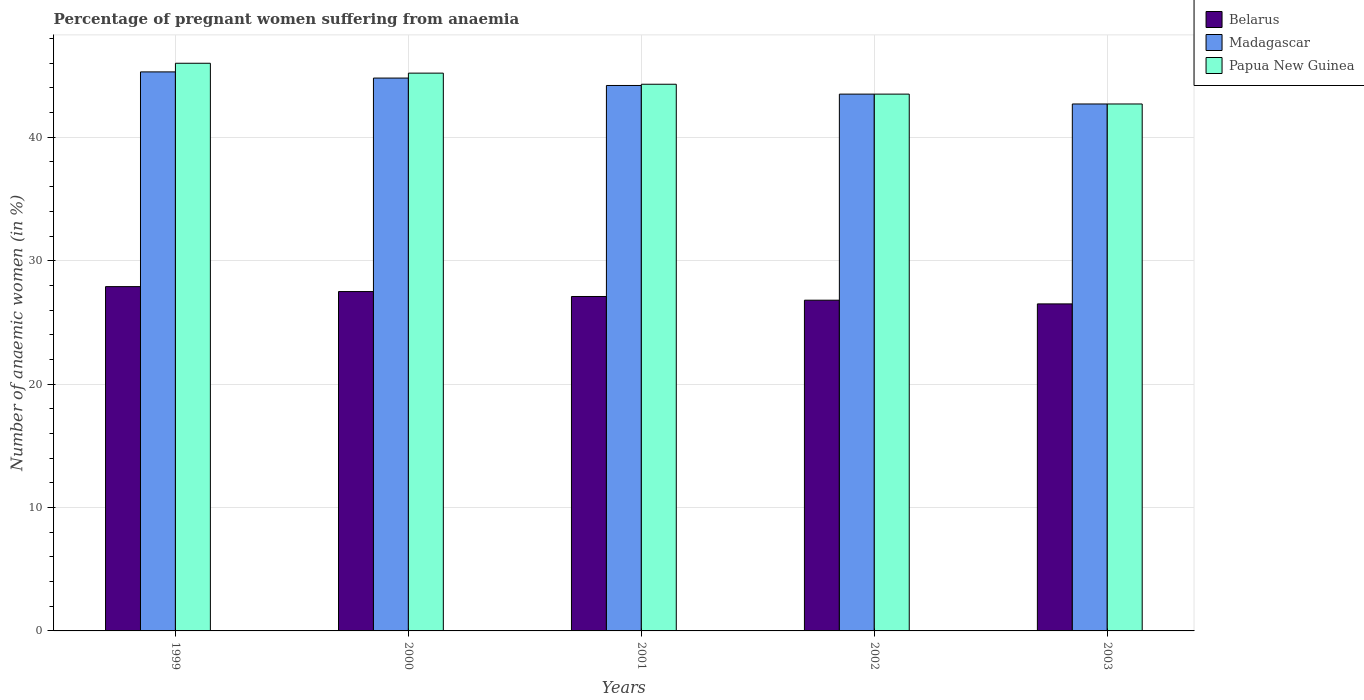Are the number of bars per tick equal to the number of legend labels?
Your answer should be very brief. Yes. Are the number of bars on each tick of the X-axis equal?
Your response must be concise. Yes. How many bars are there on the 4th tick from the left?
Ensure brevity in your answer.  3. What is the label of the 2nd group of bars from the left?
Offer a very short reply. 2000. What is the number of anaemic women in Madagascar in 1999?
Make the answer very short. 45.3. Across all years, what is the maximum number of anaemic women in Belarus?
Provide a succinct answer. 27.9. Across all years, what is the minimum number of anaemic women in Papua New Guinea?
Ensure brevity in your answer.  42.7. What is the total number of anaemic women in Papua New Guinea in the graph?
Your answer should be compact. 221.7. What is the difference between the number of anaemic women in Papua New Guinea in 2000 and that in 2002?
Your response must be concise. 1.7. What is the difference between the number of anaemic women in Papua New Guinea in 2000 and the number of anaemic women in Belarus in 2001?
Your response must be concise. 18.1. What is the average number of anaemic women in Madagascar per year?
Your answer should be very brief. 44.1. In the year 2003, what is the difference between the number of anaemic women in Belarus and number of anaemic women in Madagascar?
Give a very brief answer. -16.2. In how many years, is the number of anaemic women in Madagascar greater than 22 %?
Ensure brevity in your answer.  5. What is the ratio of the number of anaemic women in Madagascar in 2000 to that in 2003?
Your response must be concise. 1.05. Is the number of anaemic women in Madagascar in 2001 less than that in 2003?
Provide a succinct answer. No. Is the difference between the number of anaemic women in Belarus in 2000 and 2001 greater than the difference between the number of anaemic women in Madagascar in 2000 and 2001?
Provide a succinct answer. No. What is the difference between the highest and the second highest number of anaemic women in Madagascar?
Offer a very short reply. 0.5. What is the difference between the highest and the lowest number of anaemic women in Belarus?
Keep it short and to the point. 1.4. In how many years, is the number of anaemic women in Papua New Guinea greater than the average number of anaemic women in Papua New Guinea taken over all years?
Your answer should be compact. 2. What does the 1st bar from the left in 2003 represents?
Give a very brief answer. Belarus. What does the 3rd bar from the right in 2001 represents?
Offer a very short reply. Belarus. How many bars are there?
Give a very brief answer. 15. Are all the bars in the graph horizontal?
Provide a succinct answer. No. What is the difference between two consecutive major ticks on the Y-axis?
Your answer should be compact. 10. Are the values on the major ticks of Y-axis written in scientific E-notation?
Keep it short and to the point. No. How are the legend labels stacked?
Your answer should be very brief. Vertical. What is the title of the graph?
Provide a short and direct response. Percentage of pregnant women suffering from anaemia. What is the label or title of the Y-axis?
Provide a short and direct response. Number of anaemic women (in %). What is the Number of anaemic women (in %) in Belarus in 1999?
Your response must be concise. 27.9. What is the Number of anaemic women (in %) of Madagascar in 1999?
Give a very brief answer. 45.3. What is the Number of anaemic women (in %) in Papua New Guinea in 1999?
Give a very brief answer. 46. What is the Number of anaemic women (in %) of Belarus in 2000?
Provide a succinct answer. 27.5. What is the Number of anaemic women (in %) in Madagascar in 2000?
Your response must be concise. 44.8. What is the Number of anaemic women (in %) of Papua New Guinea in 2000?
Your answer should be compact. 45.2. What is the Number of anaemic women (in %) of Belarus in 2001?
Provide a succinct answer. 27.1. What is the Number of anaemic women (in %) in Madagascar in 2001?
Offer a very short reply. 44.2. What is the Number of anaemic women (in %) of Papua New Guinea in 2001?
Your response must be concise. 44.3. What is the Number of anaemic women (in %) in Belarus in 2002?
Offer a terse response. 26.8. What is the Number of anaemic women (in %) of Madagascar in 2002?
Keep it short and to the point. 43.5. What is the Number of anaemic women (in %) of Papua New Guinea in 2002?
Offer a terse response. 43.5. What is the Number of anaemic women (in %) in Belarus in 2003?
Give a very brief answer. 26.5. What is the Number of anaemic women (in %) in Madagascar in 2003?
Your response must be concise. 42.7. What is the Number of anaemic women (in %) in Papua New Guinea in 2003?
Your response must be concise. 42.7. Across all years, what is the maximum Number of anaemic women (in %) of Belarus?
Ensure brevity in your answer.  27.9. Across all years, what is the maximum Number of anaemic women (in %) in Madagascar?
Give a very brief answer. 45.3. Across all years, what is the minimum Number of anaemic women (in %) in Belarus?
Your response must be concise. 26.5. Across all years, what is the minimum Number of anaemic women (in %) in Madagascar?
Your answer should be compact. 42.7. Across all years, what is the minimum Number of anaemic women (in %) in Papua New Guinea?
Your response must be concise. 42.7. What is the total Number of anaemic women (in %) of Belarus in the graph?
Your answer should be compact. 135.8. What is the total Number of anaemic women (in %) in Madagascar in the graph?
Your answer should be compact. 220.5. What is the total Number of anaemic women (in %) in Papua New Guinea in the graph?
Give a very brief answer. 221.7. What is the difference between the Number of anaemic women (in %) in Belarus in 1999 and that in 2001?
Your response must be concise. 0.8. What is the difference between the Number of anaemic women (in %) in Madagascar in 1999 and that in 2001?
Your answer should be very brief. 1.1. What is the difference between the Number of anaemic women (in %) of Papua New Guinea in 1999 and that in 2001?
Keep it short and to the point. 1.7. What is the difference between the Number of anaemic women (in %) in Papua New Guinea in 1999 and that in 2003?
Your answer should be compact. 3.3. What is the difference between the Number of anaemic women (in %) in Belarus in 2000 and that in 2002?
Give a very brief answer. 0.7. What is the difference between the Number of anaemic women (in %) in Papua New Guinea in 2000 and that in 2003?
Make the answer very short. 2.5. What is the difference between the Number of anaemic women (in %) of Madagascar in 2001 and that in 2002?
Your response must be concise. 0.7. What is the difference between the Number of anaemic women (in %) in Papua New Guinea in 2001 and that in 2003?
Offer a terse response. 1.6. What is the difference between the Number of anaemic women (in %) in Belarus in 2002 and that in 2003?
Your response must be concise. 0.3. What is the difference between the Number of anaemic women (in %) of Papua New Guinea in 2002 and that in 2003?
Your answer should be very brief. 0.8. What is the difference between the Number of anaemic women (in %) in Belarus in 1999 and the Number of anaemic women (in %) in Madagascar in 2000?
Your answer should be very brief. -16.9. What is the difference between the Number of anaemic women (in %) of Belarus in 1999 and the Number of anaemic women (in %) of Papua New Guinea in 2000?
Provide a succinct answer. -17.3. What is the difference between the Number of anaemic women (in %) of Belarus in 1999 and the Number of anaemic women (in %) of Madagascar in 2001?
Provide a short and direct response. -16.3. What is the difference between the Number of anaemic women (in %) of Belarus in 1999 and the Number of anaemic women (in %) of Papua New Guinea in 2001?
Keep it short and to the point. -16.4. What is the difference between the Number of anaemic women (in %) in Madagascar in 1999 and the Number of anaemic women (in %) in Papua New Guinea in 2001?
Provide a succinct answer. 1. What is the difference between the Number of anaemic women (in %) in Belarus in 1999 and the Number of anaemic women (in %) in Madagascar in 2002?
Keep it short and to the point. -15.6. What is the difference between the Number of anaemic women (in %) in Belarus in 1999 and the Number of anaemic women (in %) in Papua New Guinea in 2002?
Make the answer very short. -15.6. What is the difference between the Number of anaemic women (in %) of Belarus in 1999 and the Number of anaemic women (in %) of Madagascar in 2003?
Offer a terse response. -14.8. What is the difference between the Number of anaemic women (in %) of Belarus in 1999 and the Number of anaemic women (in %) of Papua New Guinea in 2003?
Provide a succinct answer. -14.8. What is the difference between the Number of anaemic women (in %) of Madagascar in 1999 and the Number of anaemic women (in %) of Papua New Guinea in 2003?
Ensure brevity in your answer.  2.6. What is the difference between the Number of anaemic women (in %) in Belarus in 2000 and the Number of anaemic women (in %) in Madagascar in 2001?
Provide a short and direct response. -16.7. What is the difference between the Number of anaemic women (in %) in Belarus in 2000 and the Number of anaemic women (in %) in Papua New Guinea in 2001?
Your answer should be compact. -16.8. What is the difference between the Number of anaemic women (in %) in Madagascar in 2000 and the Number of anaemic women (in %) in Papua New Guinea in 2001?
Your answer should be compact. 0.5. What is the difference between the Number of anaemic women (in %) in Belarus in 2000 and the Number of anaemic women (in %) in Madagascar in 2002?
Keep it short and to the point. -16. What is the difference between the Number of anaemic women (in %) of Madagascar in 2000 and the Number of anaemic women (in %) of Papua New Guinea in 2002?
Make the answer very short. 1.3. What is the difference between the Number of anaemic women (in %) of Belarus in 2000 and the Number of anaemic women (in %) of Madagascar in 2003?
Your answer should be very brief. -15.2. What is the difference between the Number of anaemic women (in %) in Belarus in 2000 and the Number of anaemic women (in %) in Papua New Guinea in 2003?
Your answer should be very brief. -15.2. What is the difference between the Number of anaemic women (in %) in Belarus in 2001 and the Number of anaemic women (in %) in Madagascar in 2002?
Your answer should be very brief. -16.4. What is the difference between the Number of anaemic women (in %) in Belarus in 2001 and the Number of anaemic women (in %) in Papua New Guinea in 2002?
Your answer should be compact. -16.4. What is the difference between the Number of anaemic women (in %) in Belarus in 2001 and the Number of anaemic women (in %) in Madagascar in 2003?
Keep it short and to the point. -15.6. What is the difference between the Number of anaemic women (in %) in Belarus in 2001 and the Number of anaemic women (in %) in Papua New Guinea in 2003?
Provide a succinct answer. -15.6. What is the difference between the Number of anaemic women (in %) in Belarus in 2002 and the Number of anaemic women (in %) in Madagascar in 2003?
Ensure brevity in your answer.  -15.9. What is the difference between the Number of anaemic women (in %) of Belarus in 2002 and the Number of anaemic women (in %) of Papua New Guinea in 2003?
Offer a terse response. -15.9. What is the average Number of anaemic women (in %) of Belarus per year?
Provide a short and direct response. 27.16. What is the average Number of anaemic women (in %) in Madagascar per year?
Offer a very short reply. 44.1. What is the average Number of anaemic women (in %) in Papua New Guinea per year?
Your answer should be very brief. 44.34. In the year 1999, what is the difference between the Number of anaemic women (in %) in Belarus and Number of anaemic women (in %) in Madagascar?
Give a very brief answer. -17.4. In the year 1999, what is the difference between the Number of anaemic women (in %) in Belarus and Number of anaemic women (in %) in Papua New Guinea?
Offer a terse response. -18.1. In the year 1999, what is the difference between the Number of anaemic women (in %) of Madagascar and Number of anaemic women (in %) of Papua New Guinea?
Make the answer very short. -0.7. In the year 2000, what is the difference between the Number of anaemic women (in %) in Belarus and Number of anaemic women (in %) in Madagascar?
Your answer should be very brief. -17.3. In the year 2000, what is the difference between the Number of anaemic women (in %) of Belarus and Number of anaemic women (in %) of Papua New Guinea?
Make the answer very short. -17.7. In the year 2001, what is the difference between the Number of anaemic women (in %) in Belarus and Number of anaemic women (in %) in Madagascar?
Offer a very short reply. -17.1. In the year 2001, what is the difference between the Number of anaemic women (in %) in Belarus and Number of anaemic women (in %) in Papua New Guinea?
Ensure brevity in your answer.  -17.2. In the year 2001, what is the difference between the Number of anaemic women (in %) in Madagascar and Number of anaemic women (in %) in Papua New Guinea?
Provide a short and direct response. -0.1. In the year 2002, what is the difference between the Number of anaemic women (in %) in Belarus and Number of anaemic women (in %) in Madagascar?
Offer a terse response. -16.7. In the year 2002, what is the difference between the Number of anaemic women (in %) in Belarus and Number of anaemic women (in %) in Papua New Guinea?
Ensure brevity in your answer.  -16.7. In the year 2002, what is the difference between the Number of anaemic women (in %) of Madagascar and Number of anaemic women (in %) of Papua New Guinea?
Ensure brevity in your answer.  0. In the year 2003, what is the difference between the Number of anaemic women (in %) in Belarus and Number of anaemic women (in %) in Madagascar?
Your response must be concise. -16.2. In the year 2003, what is the difference between the Number of anaemic women (in %) in Belarus and Number of anaemic women (in %) in Papua New Guinea?
Give a very brief answer. -16.2. What is the ratio of the Number of anaemic women (in %) of Belarus in 1999 to that in 2000?
Keep it short and to the point. 1.01. What is the ratio of the Number of anaemic women (in %) of Madagascar in 1999 to that in 2000?
Your response must be concise. 1.01. What is the ratio of the Number of anaemic women (in %) of Papua New Guinea in 1999 to that in 2000?
Provide a short and direct response. 1.02. What is the ratio of the Number of anaemic women (in %) in Belarus in 1999 to that in 2001?
Provide a short and direct response. 1.03. What is the ratio of the Number of anaemic women (in %) in Madagascar in 1999 to that in 2001?
Offer a terse response. 1.02. What is the ratio of the Number of anaemic women (in %) of Papua New Guinea in 1999 to that in 2001?
Offer a very short reply. 1.04. What is the ratio of the Number of anaemic women (in %) of Belarus in 1999 to that in 2002?
Make the answer very short. 1.04. What is the ratio of the Number of anaemic women (in %) in Madagascar in 1999 to that in 2002?
Make the answer very short. 1.04. What is the ratio of the Number of anaemic women (in %) of Papua New Guinea in 1999 to that in 2002?
Give a very brief answer. 1.06. What is the ratio of the Number of anaemic women (in %) in Belarus in 1999 to that in 2003?
Your answer should be very brief. 1.05. What is the ratio of the Number of anaemic women (in %) in Madagascar in 1999 to that in 2003?
Make the answer very short. 1.06. What is the ratio of the Number of anaemic women (in %) of Papua New Guinea in 1999 to that in 2003?
Keep it short and to the point. 1.08. What is the ratio of the Number of anaemic women (in %) of Belarus in 2000 to that in 2001?
Provide a succinct answer. 1.01. What is the ratio of the Number of anaemic women (in %) in Madagascar in 2000 to that in 2001?
Offer a very short reply. 1.01. What is the ratio of the Number of anaemic women (in %) in Papua New Guinea in 2000 to that in 2001?
Provide a short and direct response. 1.02. What is the ratio of the Number of anaemic women (in %) of Belarus in 2000 to that in 2002?
Give a very brief answer. 1.03. What is the ratio of the Number of anaemic women (in %) in Madagascar in 2000 to that in 2002?
Ensure brevity in your answer.  1.03. What is the ratio of the Number of anaemic women (in %) of Papua New Guinea in 2000 to that in 2002?
Provide a succinct answer. 1.04. What is the ratio of the Number of anaemic women (in %) in Belarus in 2000 to that in 2003?
Offer a terse response. 1.04. What is the ratio of the Number of anaemic women (in %) of Madagascar in 2000 to that in 2003?
Offer a terse response. 1.05. What is the ratio of the Number of anaemic women (in %) in Papua New Guinea in 2000 to that in 2003?
Your answer should be compact. 1.06. What is the ratio of the Number of anaemic women (in %) of Belarus in 2001 to that in 2002?
Your answer should be very brief. 1.01. What is the ratio of the Number of anaemic women (in %) of Madagascar in 2001 to that in 2002?
Your response must be concise. 1.02. What is the ratio of the Number of anaemic women (in %) in Papua New Guinea in 2001 to that in 2002?
Your answer should be very brief. 1.02. What is the ratio of the Number of anaemic women (in %) of Belarus in 2001 to that in 2003?
Give a very brief answer. 1.02. What is the ratio of the Number of anaemic women (in %) of Madagascar in 2001 to that in 2003?
Provide a succinct answer. 1.04. What is the ratio of the Number of anaemic women (in %) of Papua New Guinea in 2001 to that in 2003?
Your response must be concise. 1.04. What is the ratio of the Number of anaemic women (in %) of Belarus in 2002 to that in 2003?
Ensure brevity in your answer.  1.01. What is the ratio of the Number of anaemic women (in %) in Madagascar in 2002 to that in 2003?
Your response must be concise. 1.02. What is the ratio of the Number of anaemic women (in %) of Papua New Guinea in 2002 to that in 2003?
Your answer should be very brief. 1.02. What is the difference between the highest and the second highest Number of anaemic women (in %) in Madagascar?
Provide a succinct answer. 0.5. What is the difference between the highest and the lowest Number of anaemic women (in %) of Madagascar?
Offer a very short reply. 2.6. 